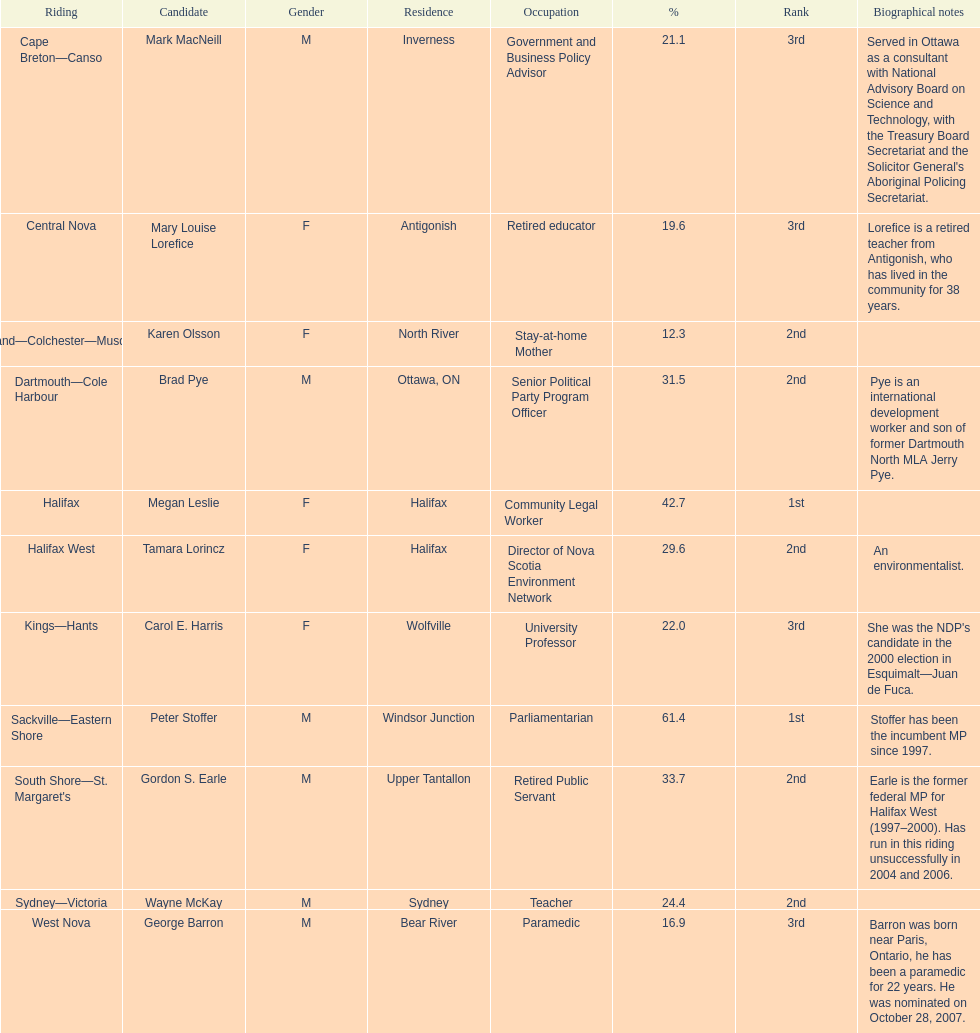What is the number of votes that megan leslie received? 19,252. Could you parse the entire table? {'header': ['Riding', 'Candidate', 'Gender', 'Residence', 'Occupation', '%', 'Rank', 'Biographical notes'], 'rows': [['Cape Breton—Canso', 'Mark MacNeill', 'M', 'Inverness', 'Government and Business Policy Advisor', '21.1', '3rd', "Served in Ottawa as a consultant with National Advisory Board on Science and Technology, with the Treasury Board Secretariat and the Solicitor General's Aboriginal Policing Secretariat."], ['Central Nova', 'Mary Louise Lorefice', 'F', 'Antigonish', 'Retired educator', '19.6', '3rd', 'Lorefice is a retired teacher from Antigonish, who has lived in the community for 38 years.'], ['Cumberland—Colchester—Musquodoboit Valley', 'Karen Olsson', 'F', 'North River', 'Stay-at-home Mother', '12.3', '2nd', ''], ['Dartmouth—Cole Harbour', 'Brad Pye', 'M', 'Ottawa, ON', 'Senior Political Party Program Officer', '31.5', '2nd', 'Pye is an international development worker and son of former Dartmouth North MLA Jerry Pye.'], ['Halifax', 'Megan Leslie', 'F', 'Halifax', 'Community Legal Worker', '42.7', '1st', ''], ['Halifax West', 'Tamara Lorincz', 'F', 'Halifax', 'Director of Nova Scotia Environment Network', '29.6', '2nd', 'An environmentalist.'], ['Kings—Hants', 'Carol E. Harris', 'F', 'Wolfville', 'University Professor', '22.0', '3rd', "She was the NDP's candidate in the 2000 election in Esquimalt—Juan de Fuca."], ['Sackville—Eastern Shore', 'Peter Stoffer', 'M', 'Windsor Junction', 'Parliamentarian', '61.4', '1st', 'Stoffer has been the incumbent MP since 1997.'], ["South Shore—St. Margaret's", 'Gordon S. Earle', 'M', 'Upper Tantallon', 'Retired Public Servant', '33.7', '2nd', 'Earle is the former federal MP for Halifax West (1997–2000). Has run in this riding unsuccessfully in 2004 and 2006.'], ['Sydney—Victoria', 'Wayne McKay', 'M', 'Sydney', 'Teacher', '24.4', '2nd', ''], ['West Nova', 'George Barron', 'M', 'Bear River', 'Paramedic', '16.9', '3rd', 'Barron was born near Paris, Ontario, he has been a paramedic for 22 years. He was nominated on October 28, 2007.']]} 